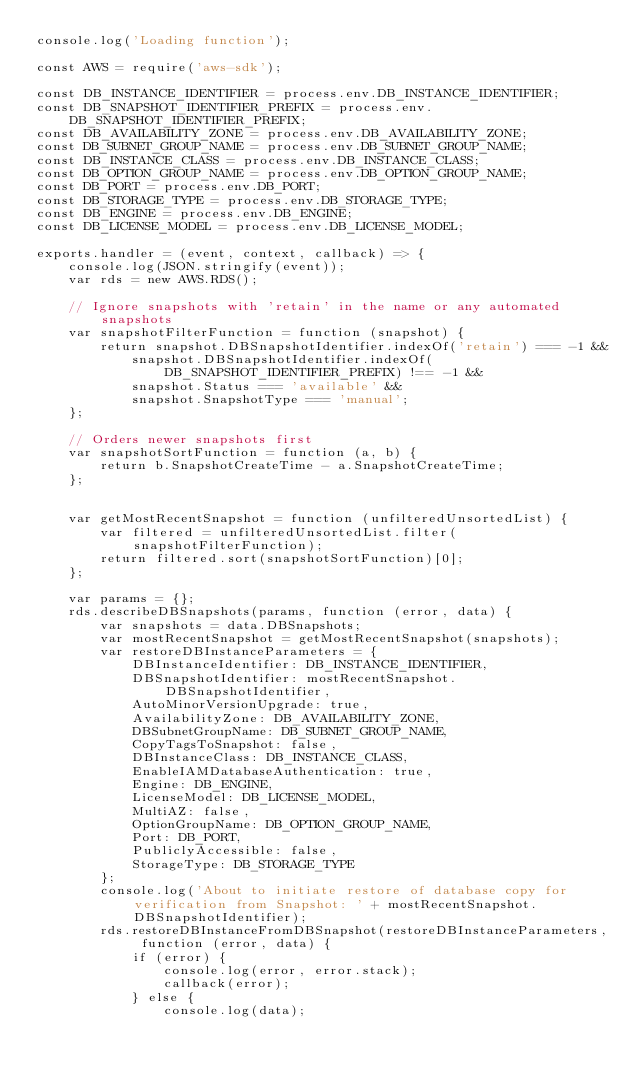<code> <loc_0><loc_0><loc_500><loc_500><_JavaScript_>console.log('Loading function');

const AWS = require('aws-sdk');

const DB_INSTANCE_IDENTIFIER = process.env.DB_INSTANCE_IDENTIFIER;
const DB_SNAPSHOT_IDENTIFIER_PREFIX = process.env.DB_SNAPSHOT_IDENTIFIER_PREFIX;
const DB_AVAILABILITY_ZONE = process.env.DB_AVAILABILITY_ZONE;
const DB_SUBNET_GROUP_NAME = process.env.DB_SUBNET_GROUP_NAME;
const DB_INSTANCE_CLASS = process.env.DB_INSTANCE_CLASS;
const DB_OPTION_GROUP_NAME = process.env.DB_OPTION_GROUP_NAME;
const DB_PORT = process.env.DB_PORT;
const DB_STORAGE_TYPE = process.env.DB_STORAGE_TYPE;
const DB_ENGINE = process.env.DB_ENGINE;
const DB_LICENSE_MODEL = process.env.DB_LICENSE_MODEL;

exports.handler = (event, context, callback) => {
    console.log(JSON.stringify(event));
    var rds = new AWS.RDS();

    // Ignore snapshots with 'retain' in the name or any automated snapshots
    var snapshotFilterFunction = function (snapshot) {
        return snapshot.DBSnapshotIdentifier.indexOf('retain') === -1 &&
            snapshot.DBSnapshotIdentifier.indexOf(DB_SNAPSHOT_IDENTIFIER_PREFIX) !== -1 &&
            snapshot.Status === 'available' &&
            snapshot.SnapshotType === 'manual';
    };

    // Orders newer snapshots first
    var snapshotSortFunction = function (a, b) {
        return b.SnapshotCreateTime - a.SnapshotCreateTime;
    };


    var getMostRecentSnapshot = function (unfilteredUnsortedList) {
        var filtered = unfilteredUnsortedList.filter(snapshotFilterFunction);
        return filtered.sort(snapshotSortFunction)[0];
    };

    var params = {};
    rds.describeDBSnapshots(params, function (error, data) {
        var snapshots = data.DBSnapshots;
        var mostRecentSnapshot = getMostRecentSnapshot(snapshots);
        var restoreDBInstanceParameters = {
            DBInstanceIdentifier: DB_INSTANCE_IDENTIFIER,
            DBSnapshotIdentifier: mostRecentSnapshot.DBSnapshotIdentifier,
            AutoMinorVersionUpgrade: true,
            AvailabilityZone: DB_AVAILABILITY_ZONE,
            DBSubnetGroupName: DB_SUBNET_GROUP_NAME,
            CopyTagsToSnapshot: false,
            DBInstanceClass: DB_INSTANCE_CLASS,
            EnableIAMDatabaseAuthentication: true,
            Engine: DB_ENGINE,
            LicenseModel: DB_LICENSE_MODEL,
            MultiAZ: false,
            OptionGroupName: DB_OPTION_GROUP_NAME,
            Port: DB_PORT,
            PubliclyAccessible: false,
            StorageType: DB_STORAGE_TYPE
        };
        console.log('About to initiate restore of database copy for verification from Snapshot: ' + mostRecentSnapshot.DBSnapshotIdentifier);
        rds.restoreDBInstanceFromDBSnapshot(restoreDBInstanceParameters, function (error, data) {
            if (error) {
                console.log(error, error.stack);
                callback(error);
            } else {
                console.log(data);</code> 